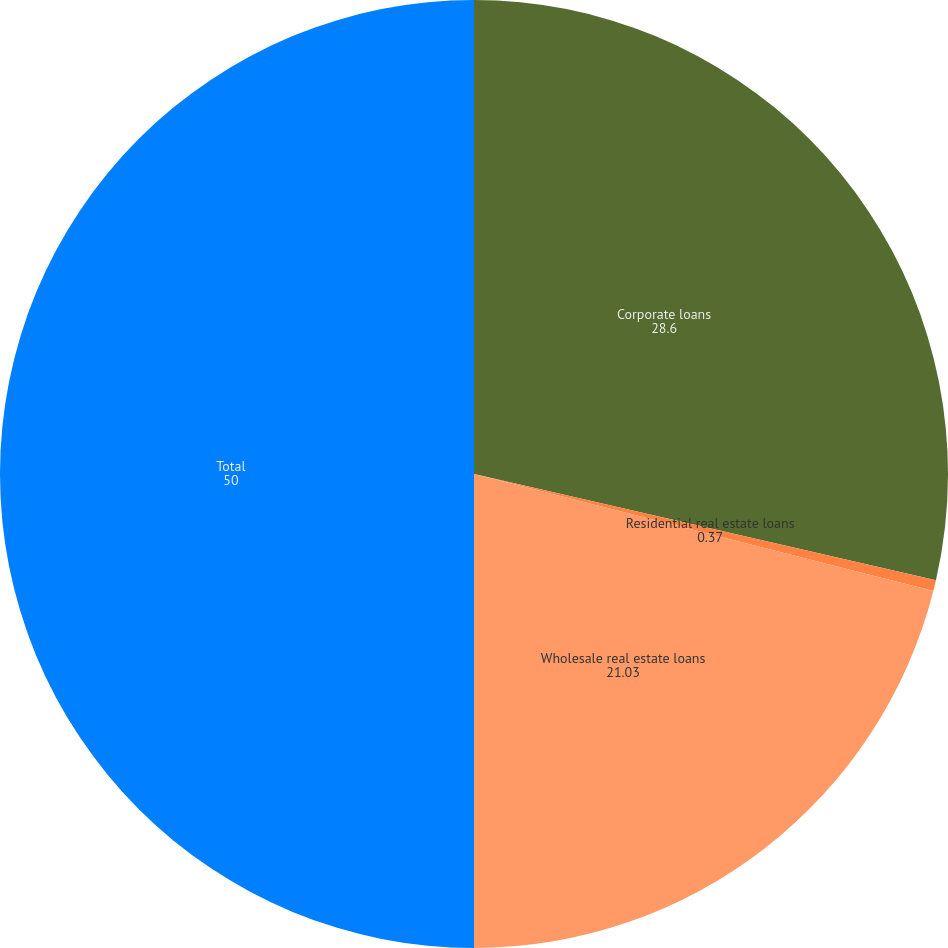Convert chart. <chart><loc_0><loc_0><loc_500><loc_500><pie_chart><fcel>Corporate loans<fcel>Residential real estate loans<fcel>Wholesale real estate loans<fcel>Total<nl><fcel>28.6%<fcel>0.37%<fcel>21.03%<fcel>50.0%<nl></chart> 